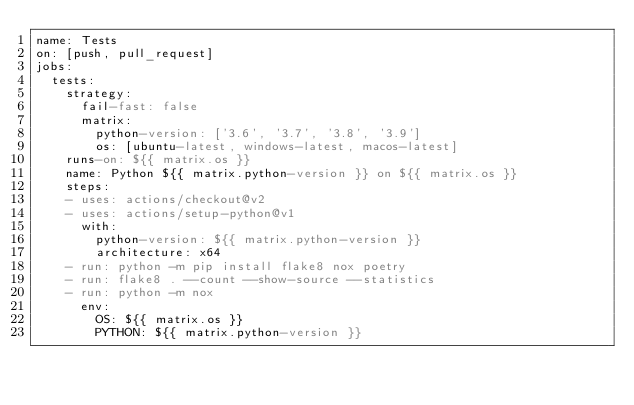<code> <loc_0><loc_0><loc_500><loc_500><_YAML_>name: Tests
on: [push, pull_request]
jobs:
  tests:
    strategy:
      fail-fast: false
      matrix:
        python-version: ['3.6', '3.7', '3.8', '3.9']
        os: [ubuntu-latest, windows-latest, macos-latest]
    runs-on: ${{ matrix.os }}
    name: Python ${{ matrix.python-version }} on ${{ matrix.os }}
    steps:
    - uses: actions/checkout@v2
    - uses: actions/setup-python@v1
      with:
        python-version: ${{ matrix.python-version }}
        architecture: x64
    - run: python -m pip install flake8 nox poetry
    - run: flake8 . --count --show-source --statistics
    - run: python -m nox
      env:
        OS: ${{ matrix.os }}
        PYTHON: ${{ matrix.python-version }}
</code> 